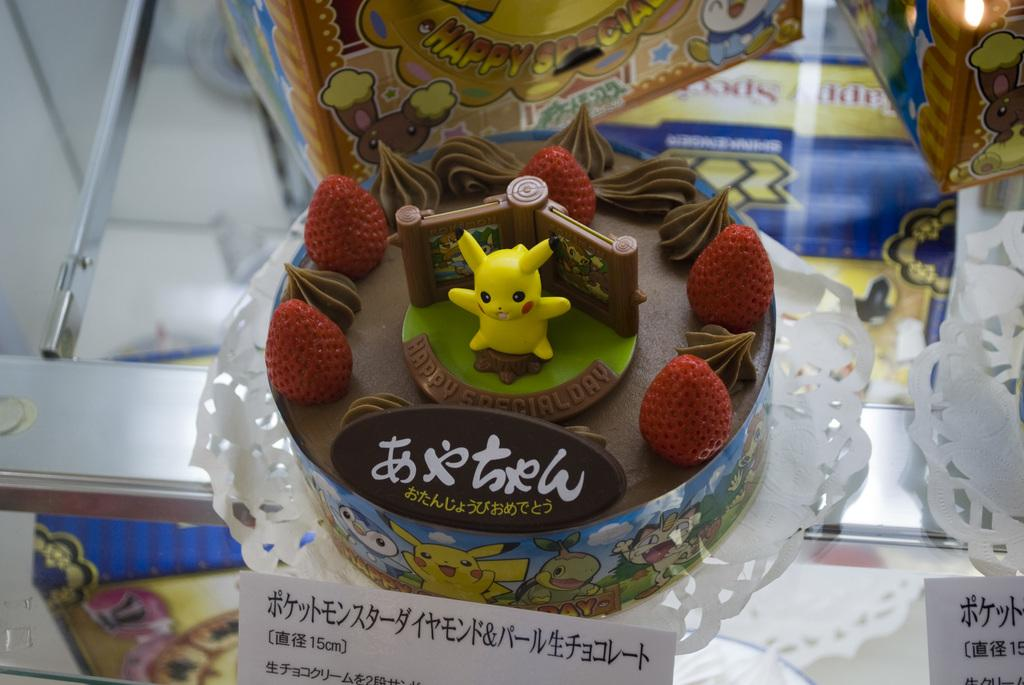What is the main subject of the image? There is a chocolate cake in the front and center in the image. What decorations are on the cake? The cake has strawberries on it. Is there is an unusual object on top of the cake? Yes, there is a yellow toy on top of the cake. What can be seen in the background of the image? There is a yellow color box in the background of the image. Can you see any attempts to comb the stream in the image? There is no stream or comb present in the image; it features a chocolate cake with strawberries, a yellow toy, and a yellow color box in the background. 